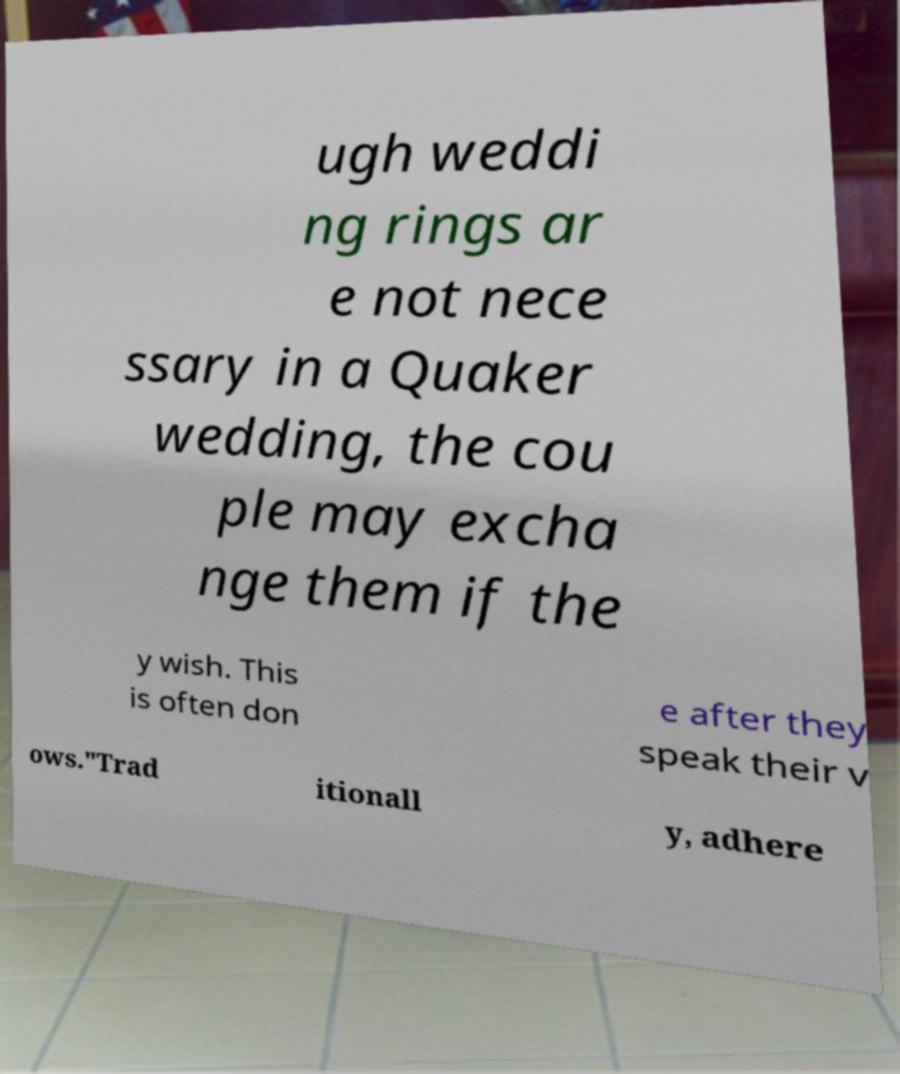What messages or text are displayed in this image? I need them in a readable, typed format. ugh weddi ng rings ar e not nece ssary in a Quaker wedding, the cou ple may excha nge them if the y wish. This is often don e after they speak their v ows."Trad itionall y, adhere 